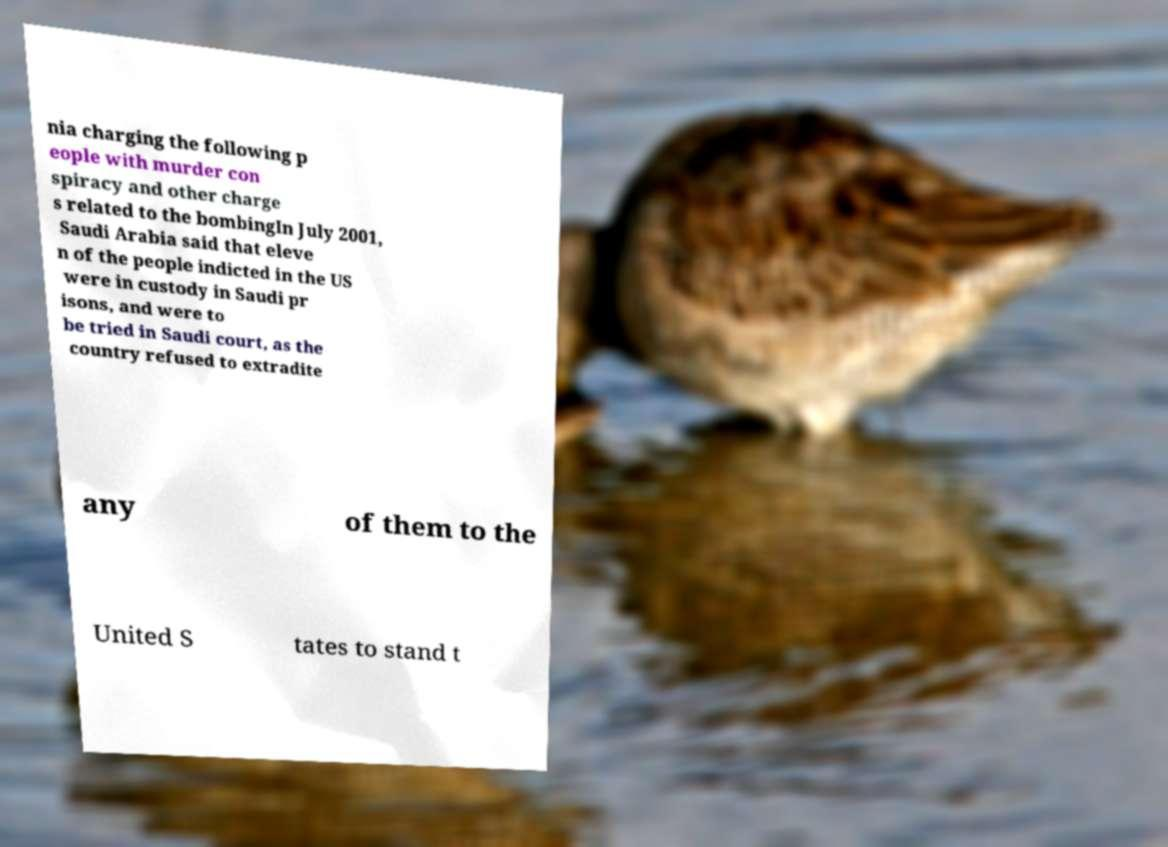Could you assist in decoding the text presented in this image and type it out clearly? nia charging the following p eople with murder con spiracy and other charge s related to the bombingIn July 2001, Saudi Arabia said that eleve n of the people indicted in the US were in custody in Saudi pr isons, and were to be tried in Saudi court, as the country refused to extradite any of them to the United S tates to stand t 